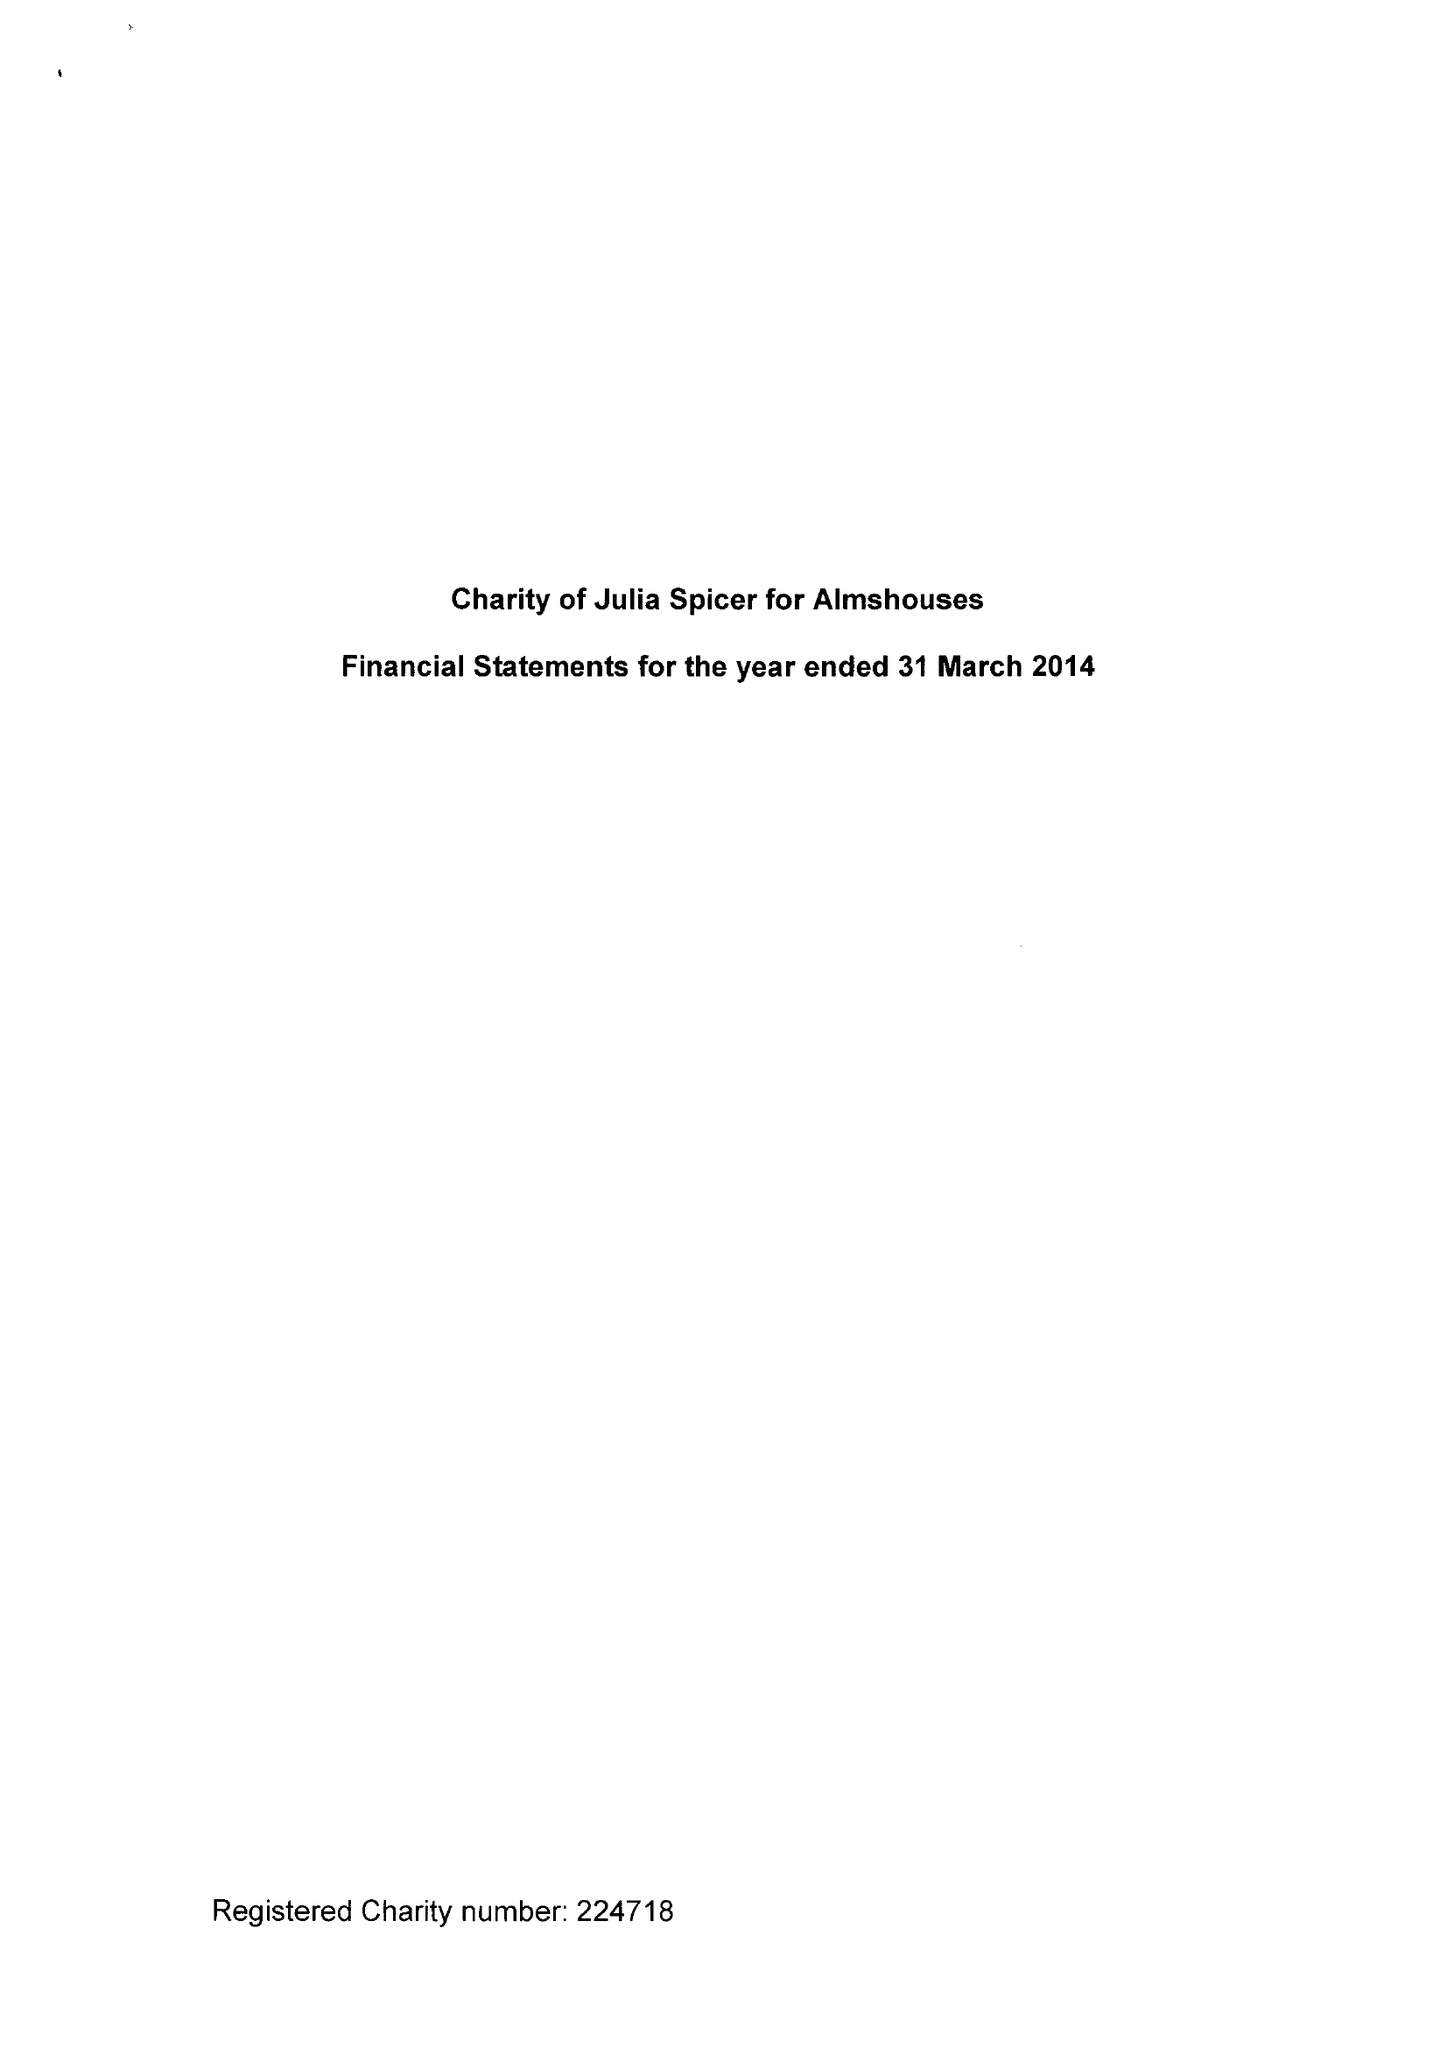What is the value for the charity_name?
Answer the question using a single word or phrase. Charity Of Julia Spicer For Almshouses 